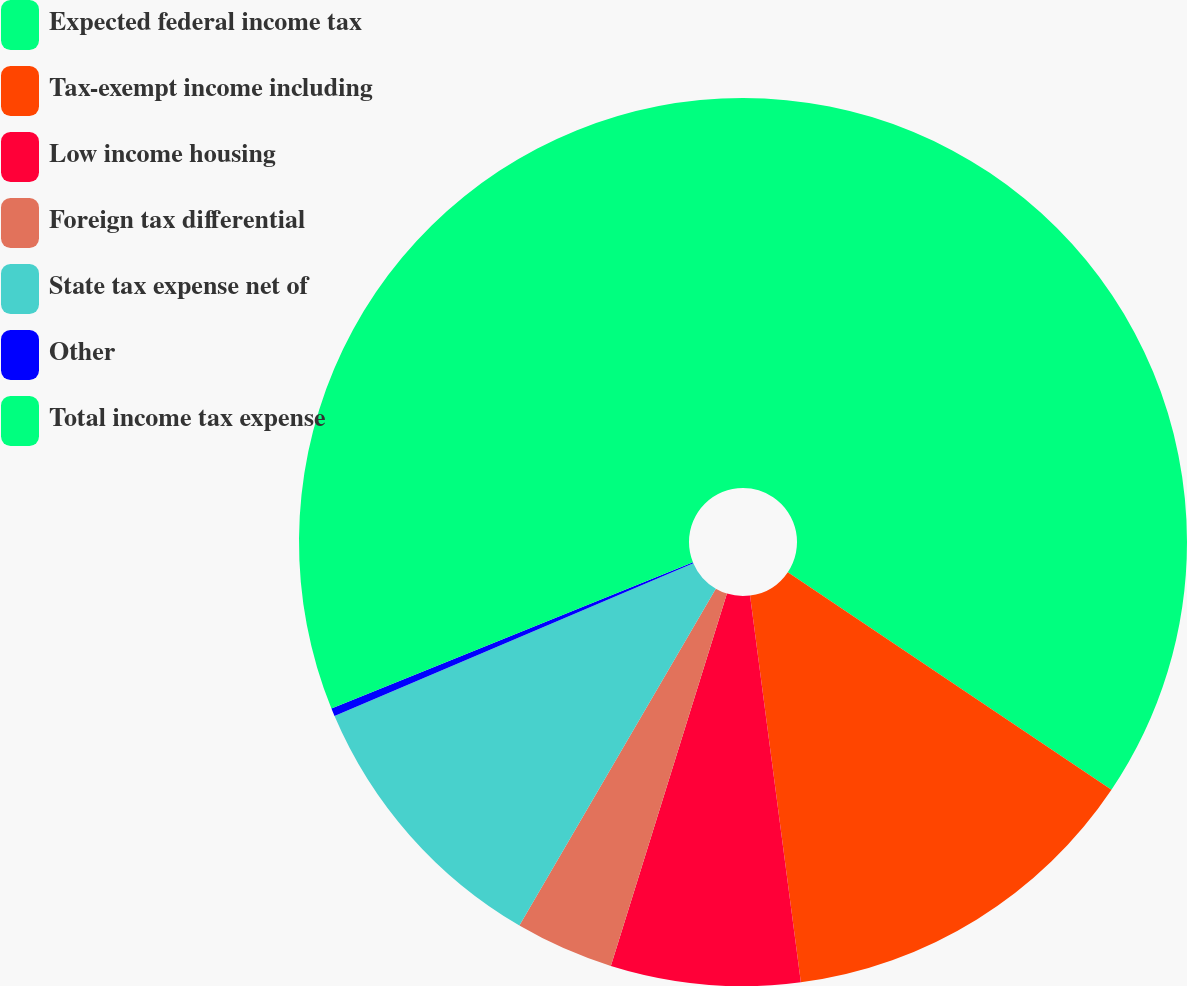<chart> <loc_0><loc_0><loc_500><loc_500><pie_chart><fcel>Expected federal income tax<fcel>Tax-exempt income including<fcel>Low income housing<fcel>Foreign tax differential<fcel>State tax expense net of<fcel>Other<fcel>Total income tax expense<nl><fcel>34.42%<fcel>13.5%<fcel>6.89%<fcel>3.59%<fcel>10.19%<fcel>0.29%<fcel>31.12%<nl></chart> 